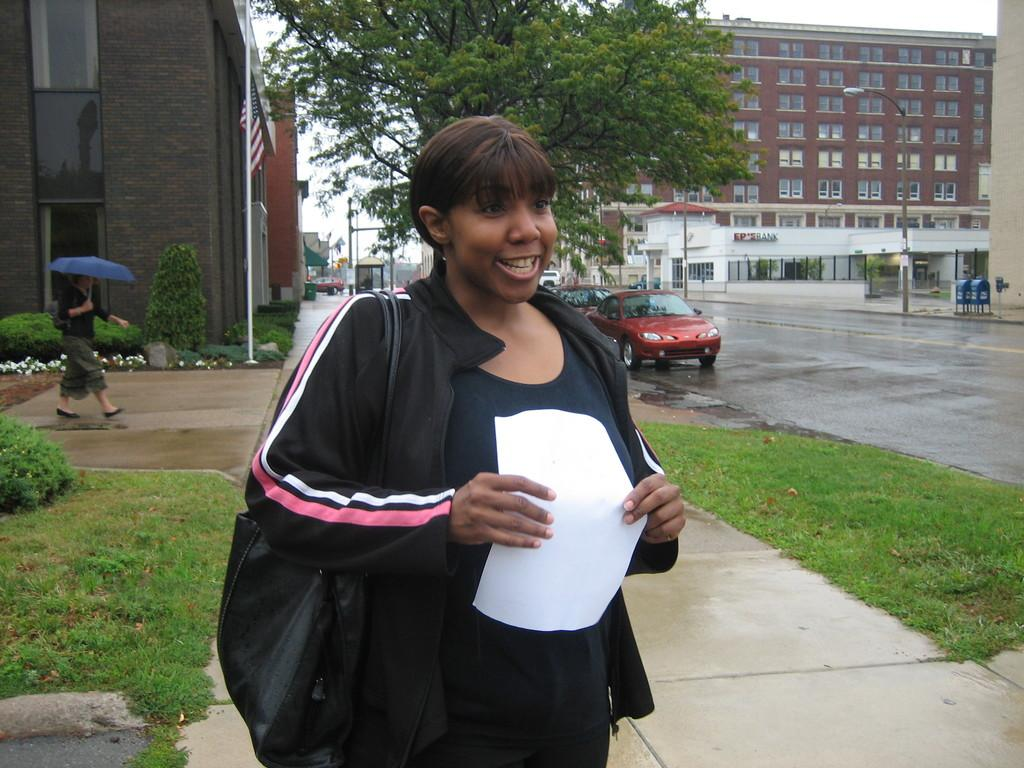What type of structures can be seen in the image? There are buildings in the image. What feature do the buildings have? The buildings have windows. What other natural elements are present in the image? There are trees in the image. What can be seen flying in the image? There is a flag in the image. What part of the natural environment is visible in the image? The sky is visible in the image. What mode of transportation can be seen in the image? There are vehicles on the road in the image. Are there any individuals present in the image? Yes, there are people in the image. Can you describe what one person is holding? One person is holding a white-colored paper. Can you tell me how many giraffes are walking on the road in the image? There are no giraffes present in the image; it features vehicles on the road. What type of print can be seen on the white-colored paper held by the person in the image? There is no print visible on the white-colored paper held by the person in the image. 